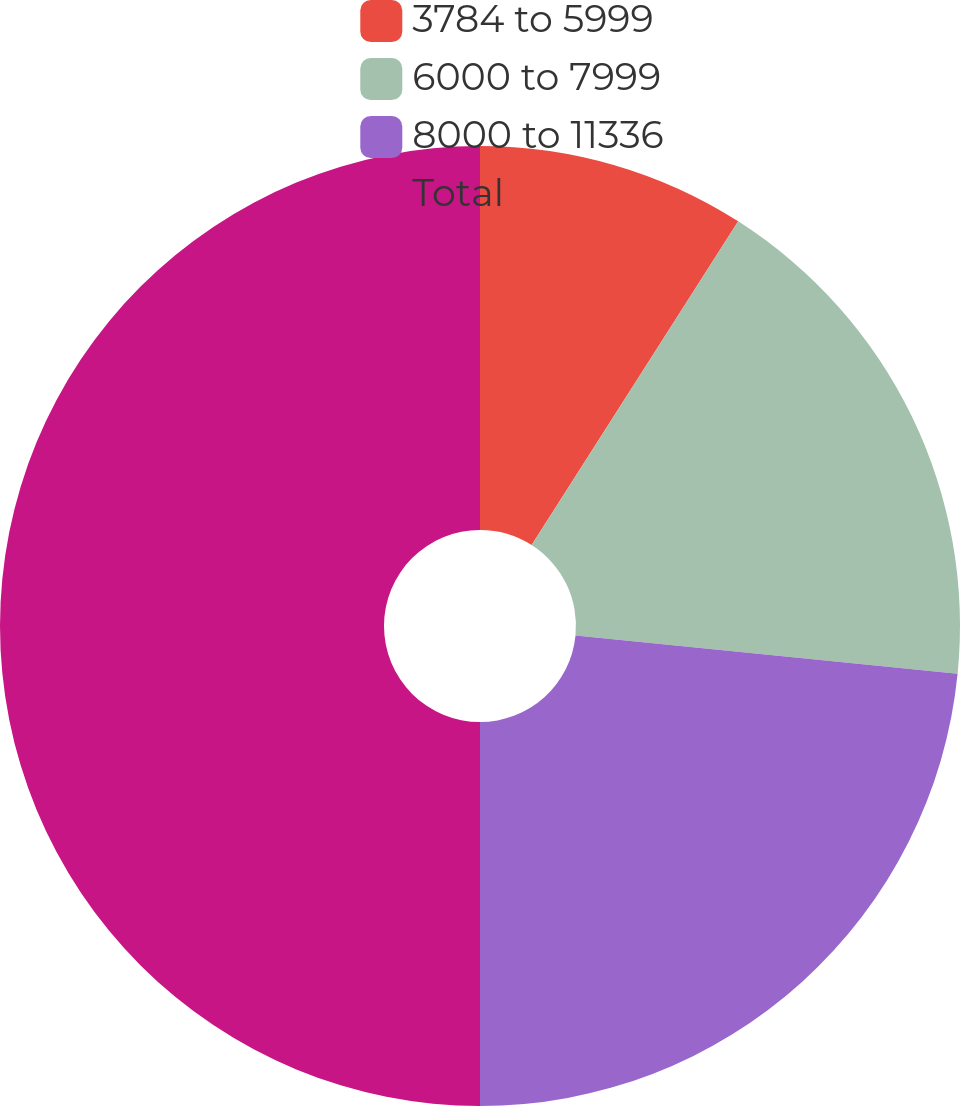Convert chart. <chart><loc_0><loc_0><loc_500><loc_500><pie_chart><fcel>3784 to 5999<fcel>6000 to 7999<fcel>8000 to 11336<fcel>Total<nl><fcel>9.04%<fcel>17.55%<fcel>23.41%<fcel>50.0%<nl></chart> 